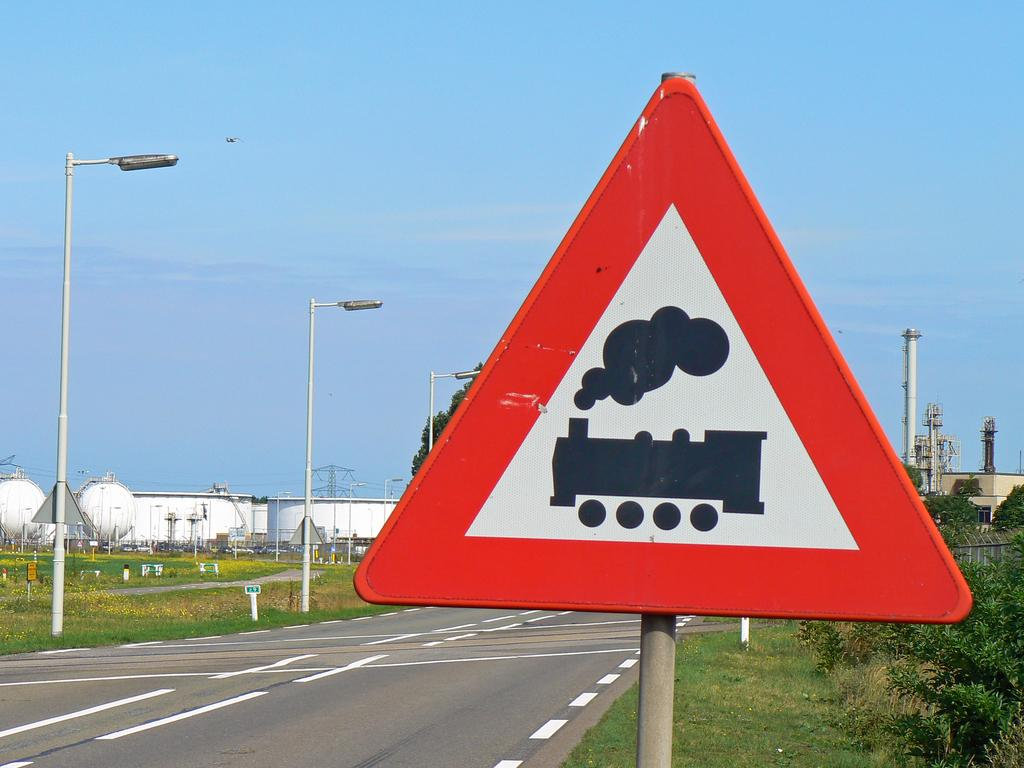What is on the pole in the image? There is a signboard on a pole in the image. What can be seen in the image besides the signboard? There is a road, poles, lights, plants, trees, a factory, and reactors in the image. What is the setting of the image? The image shows a road with various structures and vegetation, including a factory and reactors. What is visible in the background of the image? The sky is visible in the background of the image. What type of match is being played in the image? There is no match being played in the image; it features a signboard on a pole, a road, poles, lights, plants, trees, a factory, and reactors. What story is being told by the reactors in the image? The reactors in the image are not telling a story; they are part of a factory setting and do not have any narrative function. 